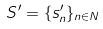Convert formula to latex. <formula><loc_0><loc_0><loc_500><loc_500>S ^ { \prime } = \{ s _ { n } ^ { \prime } \} _ { n \in N }</formula> 